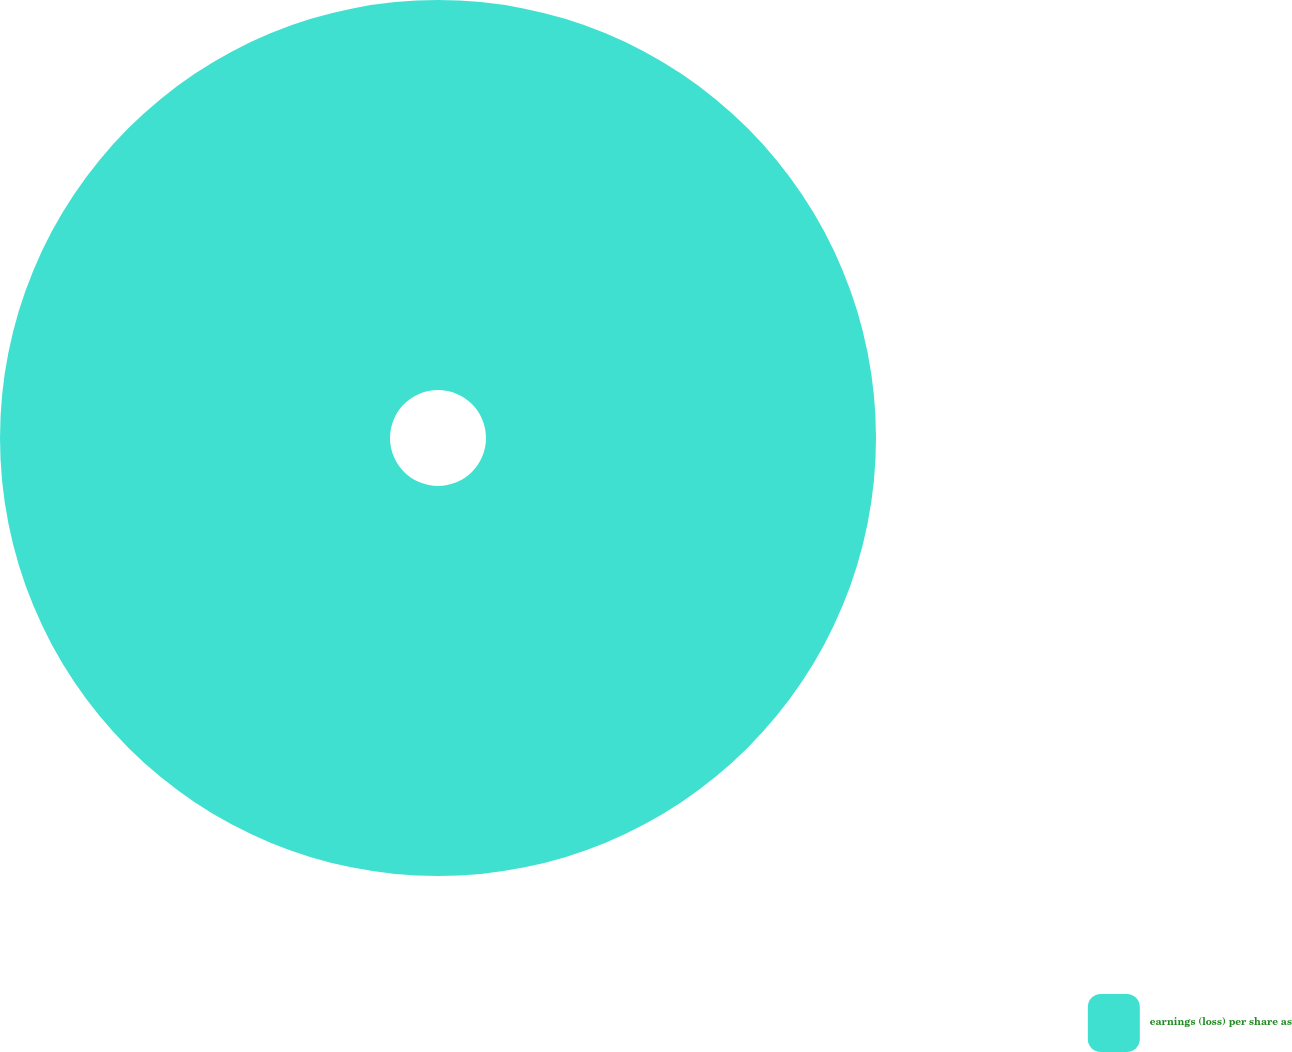<chart> <loc_0><loc_0><loc_500><loc_500><pie_chart><fcel>earnings (loss) per share as<nl><fcel>100.0%<nl></chart> 